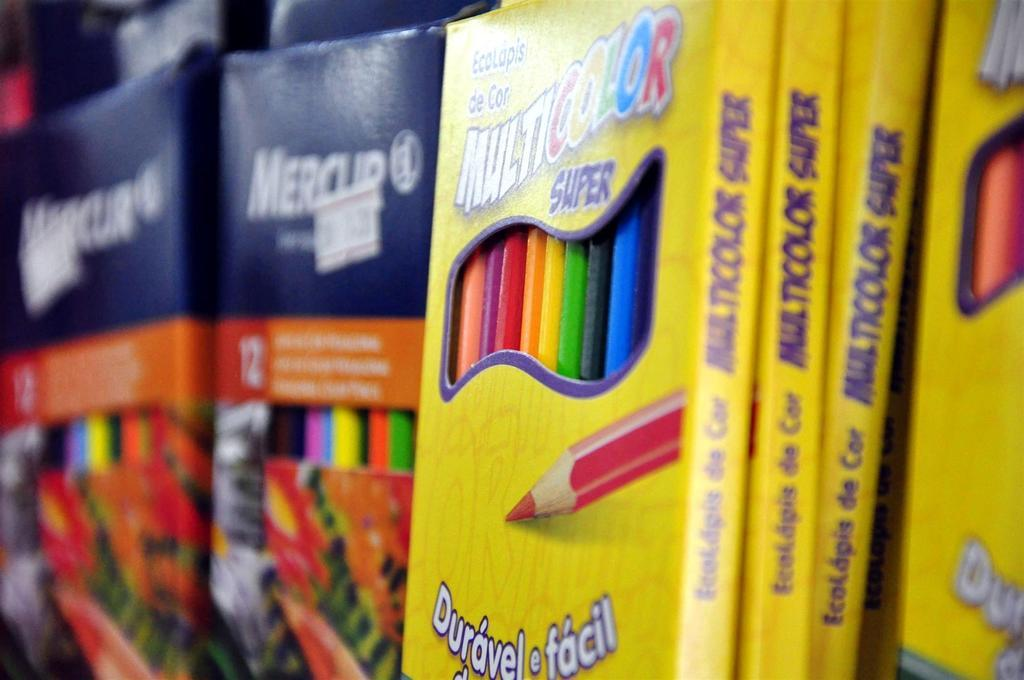<image>
Offer a succinct explanation of the picture presented. A box of colored pencils has the word super on the package. 